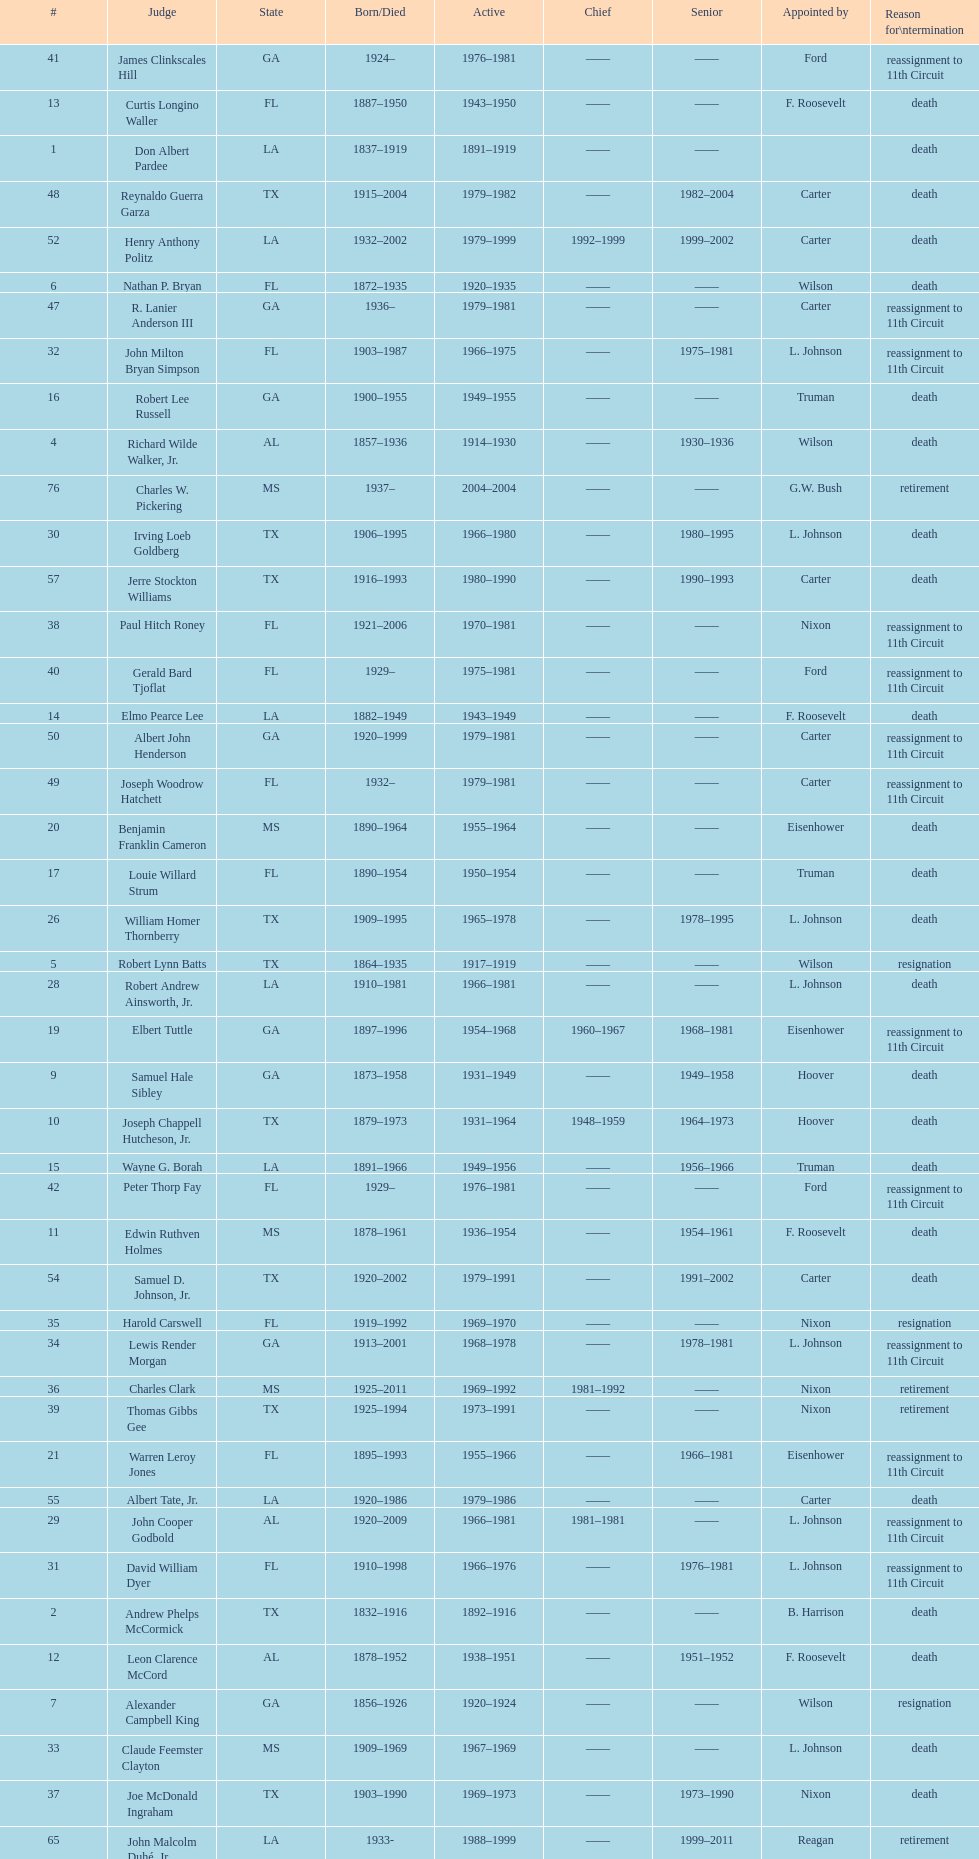Which state has the largest amount of judges to serve? TX. 